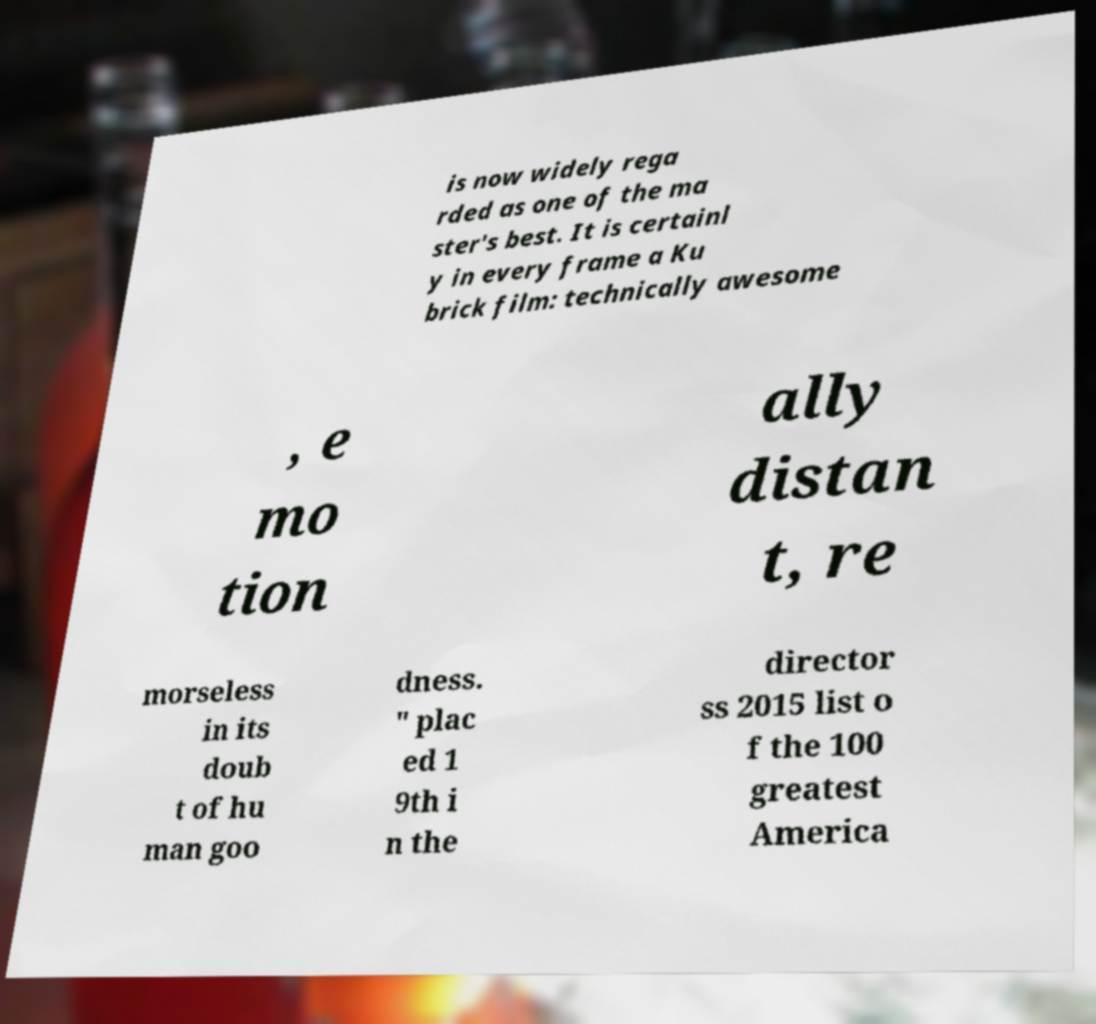Please identify and transcribe the text found in this image. is now widely rega rded as one of the ma ster's best. It is certainl y in every frame a Ku brick film: technically awesome , e mo tion ally distan t, re morseless in its doub t of hu man goo dness. " plac ed 1 9th i n the director ss 2015 list o f the 100 greatest America 